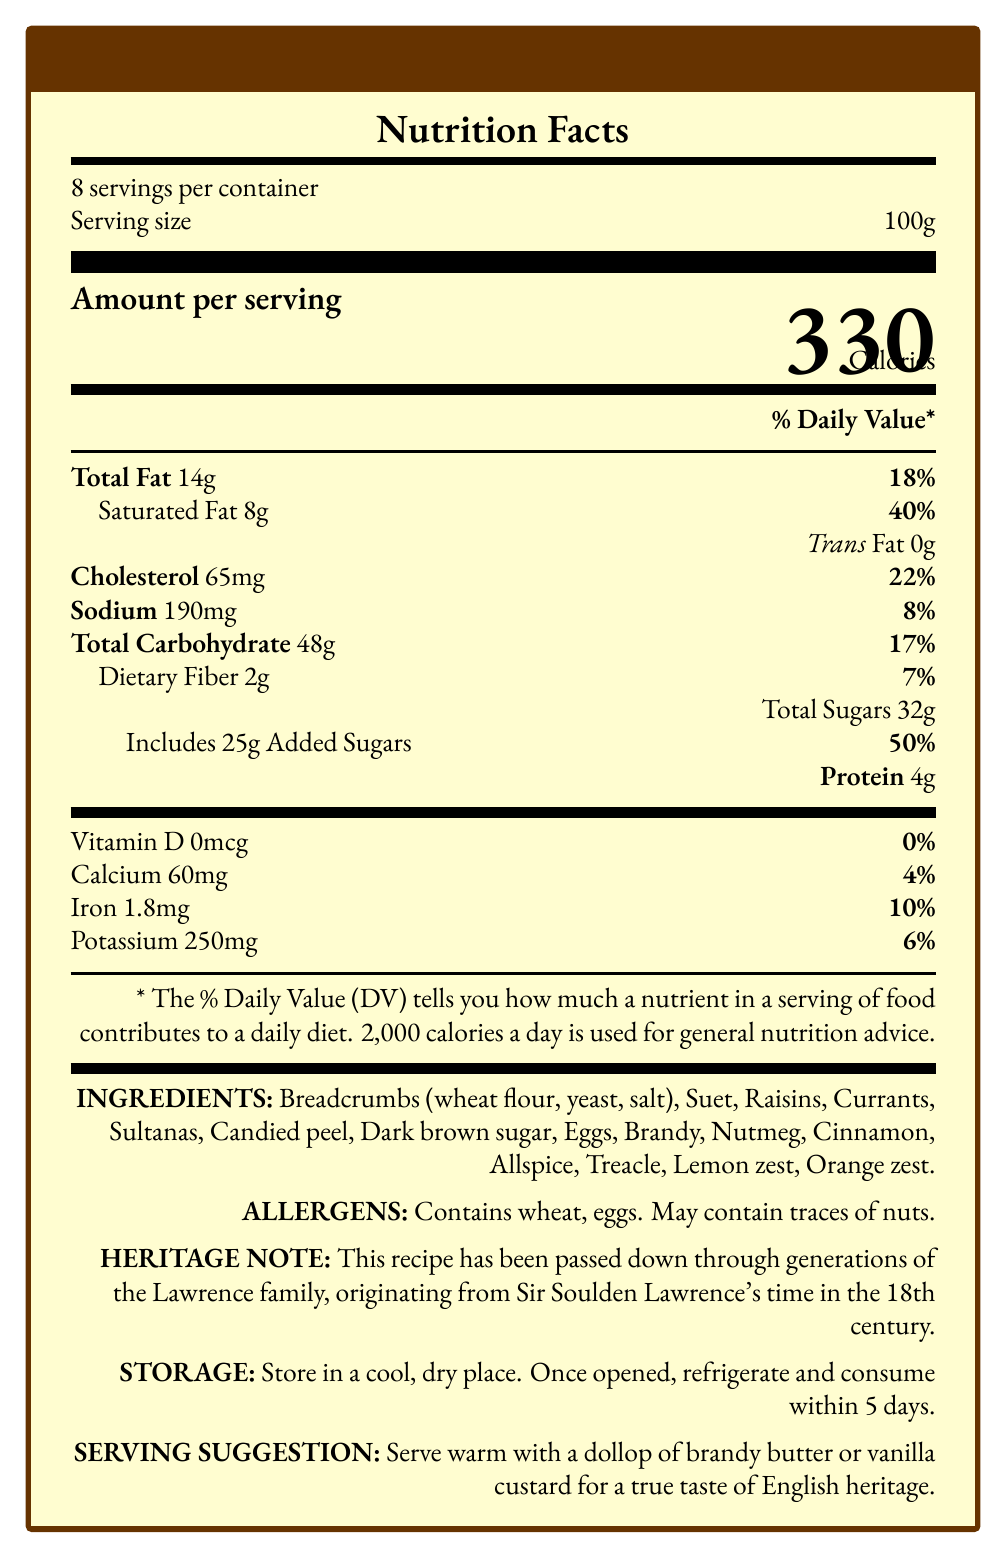What is the serving size of Sir Lawrence's Heritage Christmas Pudding? The serving size is specified directly in the document as "Serving size 100g."
Answer: 100g How many servings are there per container of the pudding? The document states "8 servings per container."
Answer: 8 What percentage of the Daily Value does the saturated fat in one serving of the pudding provide? The document lists "Saturated Fat 8g" and "40%" for the Daily Value.
Answer: 40% How much protein is in one serving of the pudding? The protein content is specified in the document as "Protein 4g."
Answer: 4g What ingredients give the pudding its unique heritage flavor? These heritage ingredients are listed under "INGREDIENTS" in the document.
Answer: Breadcrumbs, Suet, Raisins, Currants, Sultanas, Candied peel, Dark brown sugar, Eggs, Brandy, Nutmeg, Cinnamon, Allspice, Treacle, Lemon zest, Orange zest Which of these is an allergen present in the pudding? A. Soy B. Wheat C. Dairy D. Shellfish The document lists "Contains wheat, eggs" under "ALLERGENS."
Answer: B. Wheat How should the pudding be stored once opened? A. At room temperature B. In the pantry C. In the refrigerator D. In the freezer The document's storage instructions state, "Once opened, refrigerate and consume within 5 days."
Answer: C. In the refrigerator Does the pudding contain any trans fat? The document explicitly states "Trans Fat 0g."
Answer: No What is the heritage note provided in the document? The heritage note is stated under "HERITAGE NOTE."
Answer: This recipe has been passed down through generations of the Lawrence family, originating from Sir Soulden Lawrence's time in the 18th century. Is this product suitable for someone with a nut allergy? The document states "May contain traces of nuts," which does not confirm absolute suitability for someone with a nut allergy.
Answer: Not enough information Summarize the main idea of this document. The document contains comprehensive details about the nutritional content, ingredients, storage, and heritage notes about the pudding, emphasizing its traditional English roots and family heritage.
Answer: The document provides the Nutrition Facts Label for Sir Lawrence's Heritage Christmas Pudding, a traditional English dessert with heritage ingredients and an 18th-century recipe. It includes detailed nutritional information, ingredients, allergens, storage instructions, and serving suggestions. What percentage of the Daily Value does one serving of the pudding contribute to the total carbohydrate intake? The document lists "Total Carbohydrate 48g" and "17%" for the Daily Value.
Answer: 17% Which nutrient has the highest Daily Value percentage in one serving? The document lists “Includes 25g Added Sugars” with “50%” Daily Value, which is the highest percentage.
Answer: Added Sugars How much calcium is in one serving of the pudding? The document specifies "Calcium 60mg" under the nutrient section.
Answer: 60mg What is the serving suggestion for this pudding? The serving suggestion is specified under "SERVING SUGGESTION" in the document.
Answer: Serve warm with a dollop of brandy butter or vanilla custard for a true taste of English heritage. What ingredients are used as spices in the pudding? These spices are listed under "INGREDIENTS" in the document.
Answer: Nutmeg, Cinnamon, Allspice 